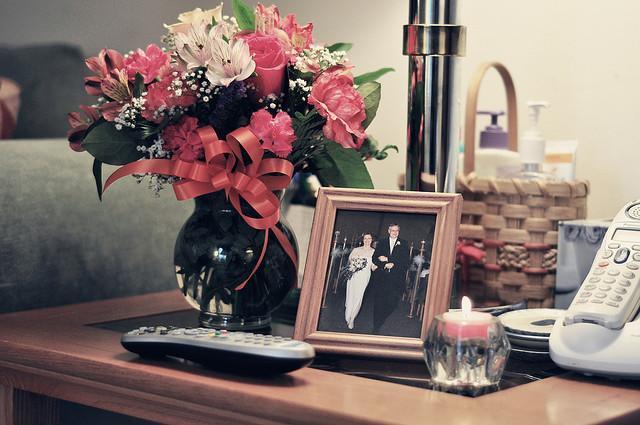How many couches are there?
Give a very brief answer. 1. 